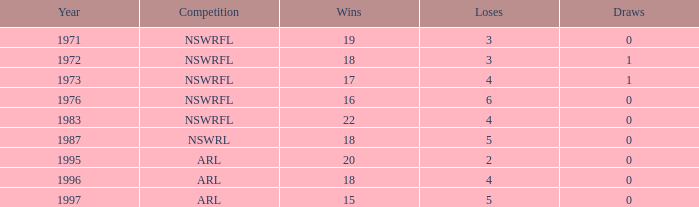What average Loses has Draws less than 0? None. Help me parse the entirety of this table. {'header': ['Year', 'Competition', 'Wins', 'Loses', 'Draws'], 'rows': [['1971', 'NSWRFL', '19', '3', '0'], ['1972', 'NSWRFL', '18', '3', '1'], ['1973', 'NSWRFL', '17', '4', '1'], ['1976', 'NSWRFL', '16', '6', '0'], ['1983', 'NSWRFL', '22', '4', '0'], ['1987', 'NSWRL', '18', '5', '0'], ['1995', 'ARL', '20', '2', '0'], ['1996', 'ARL', '18', '4', '0'], ['1997', 'ARL', '15', '5', '0']]} 